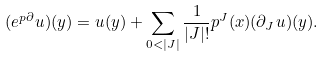Convert formula to latex. <formula><loc_0><loc_0><loc_500><loc_500>( e ^ { p \partial } u ) ( y ) = u ( y ) + \sum _ { 0 < | J | } \frac { 1 } { | J | ! } p ^ { J } ( x ) ( \partial _ { J } u ) ( y ) .</formula> 